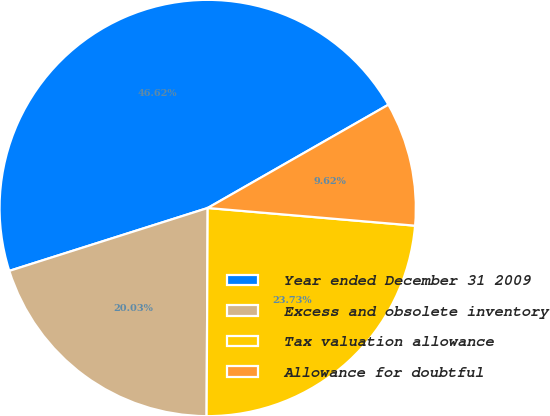<chart> <loc_0><loc_0><loc_500><loc_500><pie_chart><fcel>Year ended December 31 2009<fcel>Excess and obsolete inventory<fcel>Tax valuation allowance<fcel>Allowance for doubtful<nl><fcel>46.62%<fcel>20.03%<fcel>23.73%<fcel>9.62%<nl></chart> 